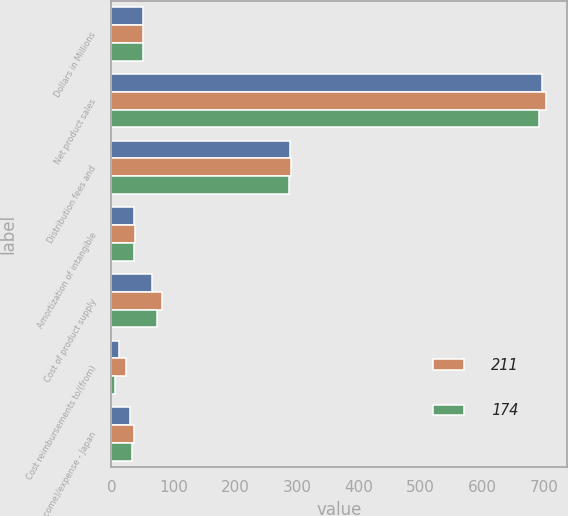Convert chart. <chart><loc_0><loc_0><loc_500><loc_500><stacked_bar_chart><ecel><fcel>Dollars in Millions<fcel>Net product sales<fcel>Distribution fees and<fcel>Amortization of intangible<fcel>Cost of product supply<fcel>Cost reimbursements to/(from)<fcel>Other (income)/expense - Japan<nl><fcel>nan<fcel>51.5<fcel>696<fcel>289<fcel>37<fcel>65<fcel>13<fcel>30<nl><fcel>211<fcel>51.5<fcel>702<fcel>291<fcel>38<fcel>81<fcel>23<fcel>37<nl><fcel>174<fcel>51.5<fcel>691<fcel>287<fcel>37<fcel>73<fcel>5<fcel>34<nl></chart> 